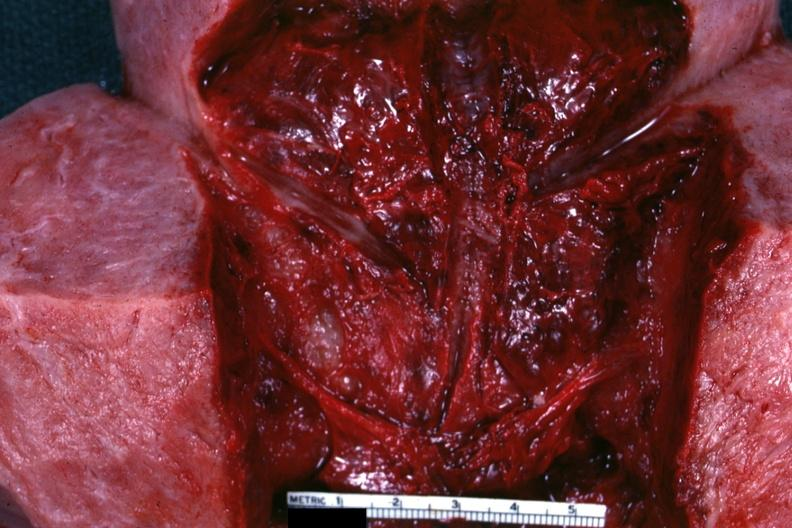s uterus present?
Answer the question using a single word or phrase. Yes 